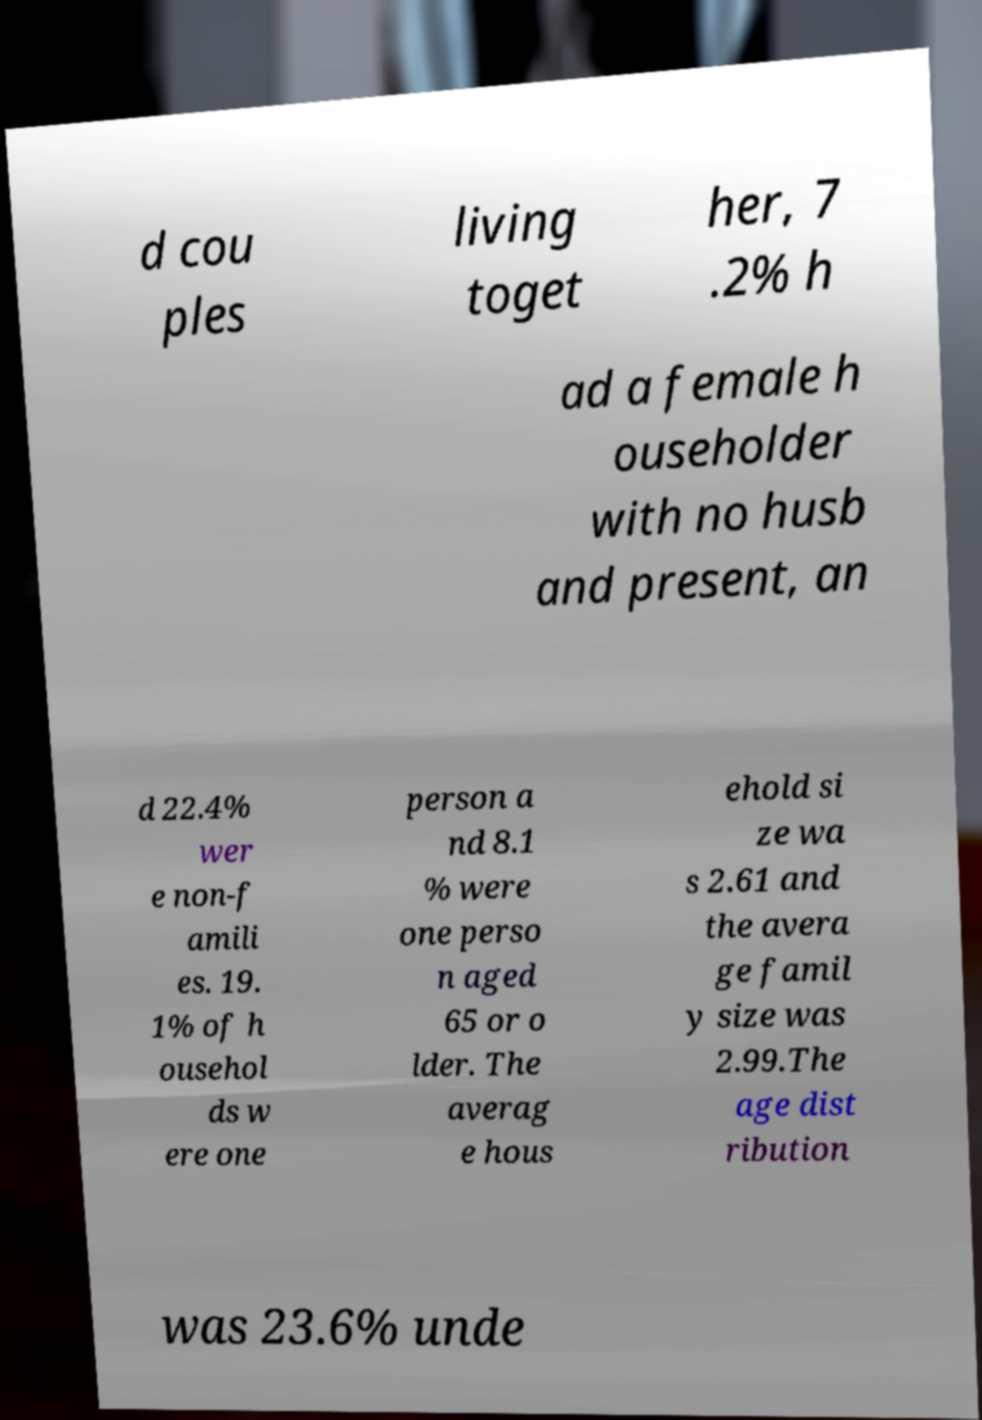Could you extract and type out the text from this image? d cou ples living toget her, 7 .2% h ad a female h ouseholder with no husb and present, an d 22.4% wer e non-f amili es. 19. 1% of h ousehol ds w ere one person a nd 8.1 % were one perso n aged 65 or o lder. The averag e hous ehold si ze wa s 2.61 and the avera ge famil y size was 2.99.The age dist ribution was 23.6% unde 